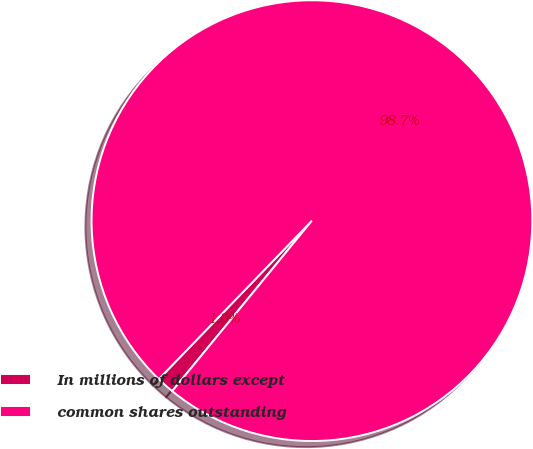Convert chart to OTSL. <chart><loc_0><loc_0><loc_500><loc_500><pie_chart><fcel>In millions of dollars except<fcel>common shares outstanding<nl><fcel>1.3%<fcel>98.7%<nl></chart> 